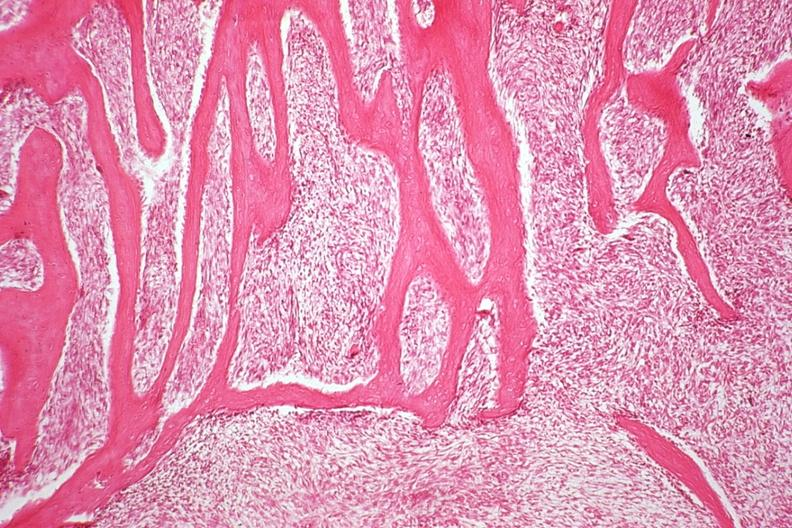does this image show section from tumor near codmans triangle reactive bone representing area of tumor with hair on end appearance?
Answer the question using a single word or phrase. Yes 